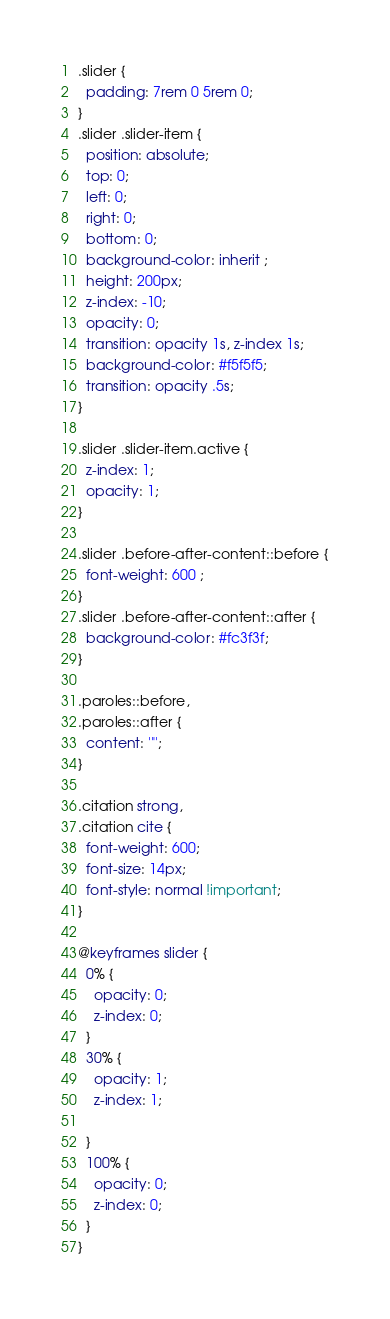<code> <loc_0><loc_0><loc_500><loc_500><_CSS_>
.slider {
  padding: 7rem 0 5rem 0;
}
.slider .slider-item {
  position: absolute;
  top: 0;
  left: 0;
  right: 0;
  bottom: 0;
  background-color: inherit ;
  height: 200px; 
  z-index: -10;
  opacity: 0;
  transition: opacity 1s, z-index 1s;
  background-color: #f5f5f5;
  transition: opacity .5s;
}

.slider .slider-item.active {
  z-index: 1;
  opacity: 1;
}

.slider .before-after-content::before {
  font-weight: 600 ;
}
.slider .before-after-content::after {
  background-color: #fc3f3f;
}

.paroles::before,
.paroles::after {
  content: '"';
}

.citation strong,
.citation cite {
  font-weight: 600;
  font-size: 14px;
  font-style: normal !important;
}

@keyframes slider {
  0% {
    opacity: 0;
    z-index: 0;
  }
  30% {
    opacity: 1;
    z-index: 1;

  }
  100% {
    opacity: 0;
    z-index: 0;
  }
}</code> 